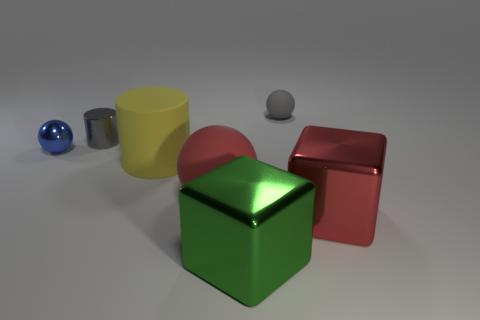What shape is the tiny rubber object that is the same color as the small shiny cylinder?
Your response must be concise. Sphere. Are there any yellow blocks that have the same material as the gray ball?
Your answer should be very brief. No. There is a object that is the same color as the shiny cylinder; what size is it?
Offer a very short reply. Small. What number of cylinders are large yellow matte objects or gray metal things?
Ensure brevity in your answer.  2. How big is the red ball?
Provide a succinct answer. Large. There is a large red matte thing; how many spheres are to the left of it?
Your response must be concise. 1. There is a rubber ball that is behind the big sphere that is in front of the gray cylinder; how big is it?
Your answer should be compact. Small. Does the big rubber thing on the left side of the big sphere have the same shape as the tiny shiny thing that is in front of the gray metal thing?
Give a very brief answer. No. The small gray object that is on the left side of the small thing that is behind the gray metal object is what shape?
Keep it short and to the point. Cylinder. There is a ball that is both on the right side of the tiny shiny cylinder and to the left of the tiny gray rubber ball; what size is it?
Your response must be concise. Large. 